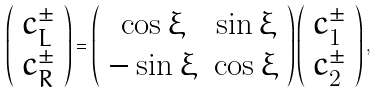Convert formula to latex. <formula><loc_0><loc_0><loc_500><loc_500>\left ( \begin{array} { c } c ^ { \pm } _ { L } \\ c ^ { \pm } _ { R } \end{array} \right ) = \left ( \begin{array} { c c } \cos \xi & \sin \xi \\ - \sin \xi & \cos \xi \end{array} \right ) \left ( \begin{array} { c } c ^ { \pm } _ { 1 } \\ c ^ { \pm } _ { 2 } \end{array} \right ) ,</formula> 